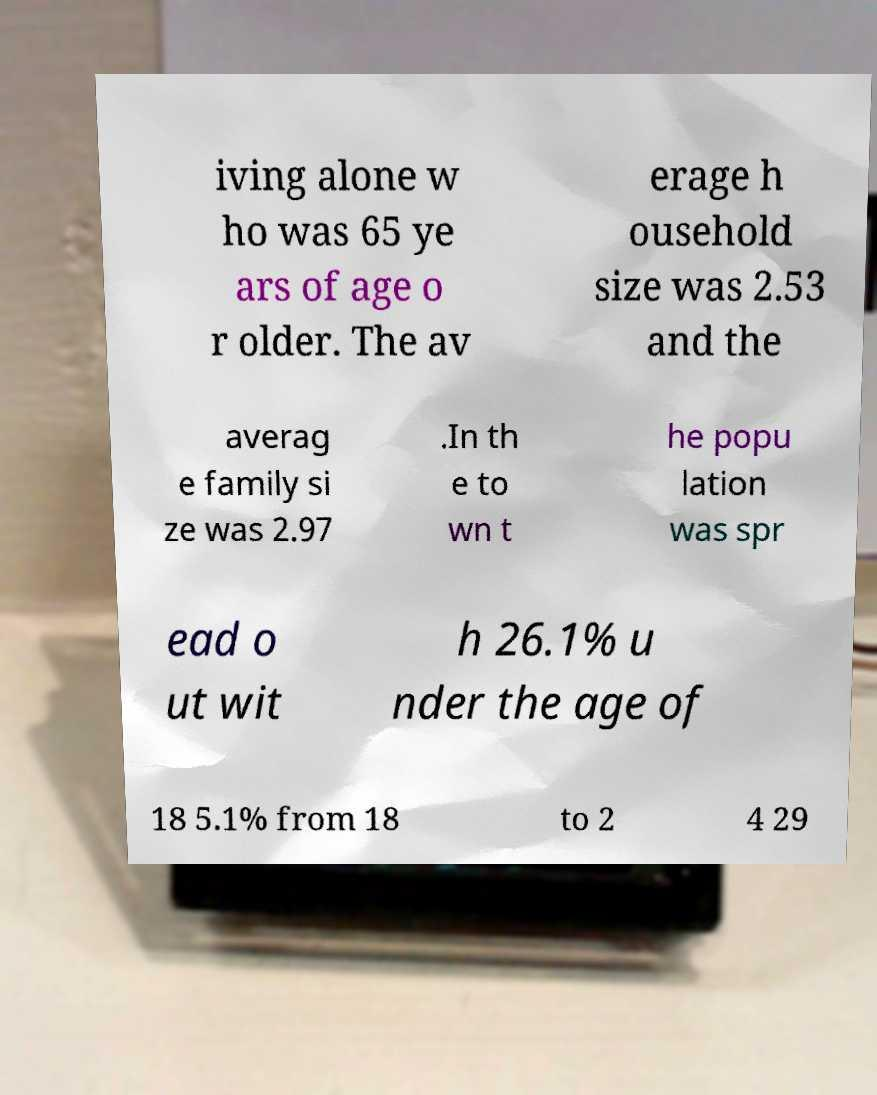Could you extract and type out the text from this image? iving alone w ho was 65 ye ars of age o r older. The av erage h ousehold size was 2.53 and the averag e family si ze was 2.97 .In th e to wn t he popu lation was spr ead o ut wit h 26.1% u nder the age of 18 5.1% from 18 to 2 4 29 